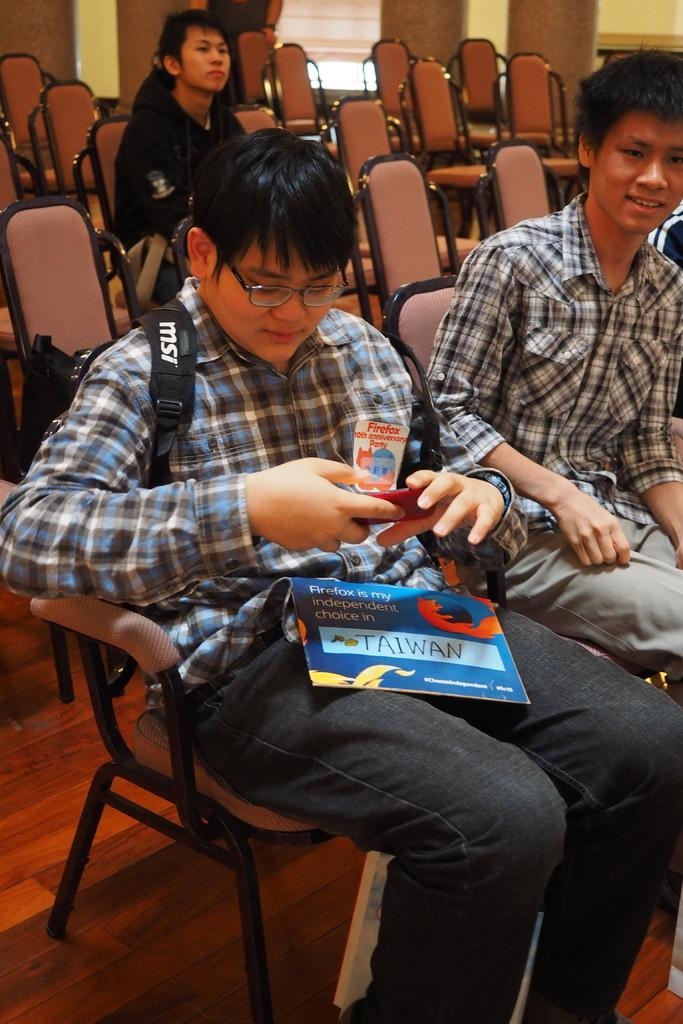How many people are in the image? There are multiple persons in the image. What are the persons doing in the image? The persons are sitting on chairs. Where does the scene take place? The scene takes place in a room. Can you describe the person with a backpack in the image? There is a person wearing a backpack in the image, and this person is sitting on a chair. What type of needle can be seen in the image? There is no needle present in the image. What is the color of the sky in the image? The image does not show the sky, so we cannot determine its color. 